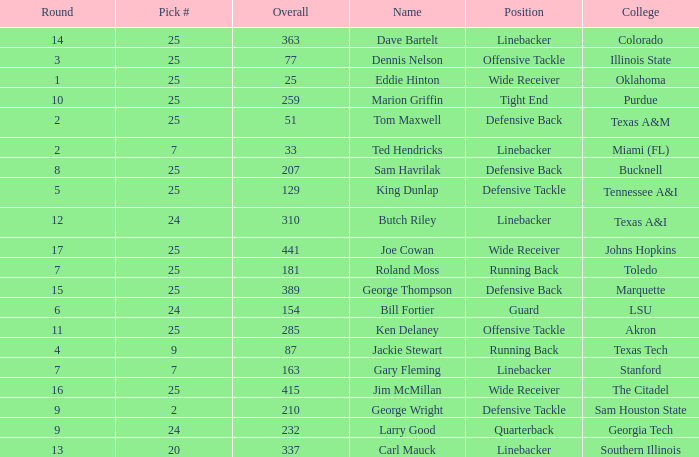Pick # of 25, and an Overall of 207 has what name? Sam Havrilak. 